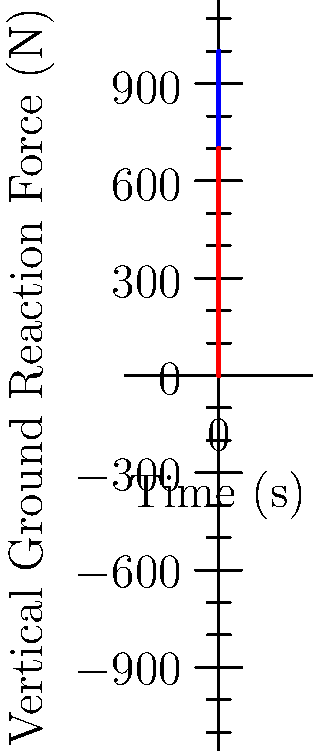The graph shows the vertical ground reaction force (vGRF) patterns during the gait cycle for a non-amputee and a prosthetic limb user. In the context of designing refugee assistance programs, what key biomechanical difference between the two patterns could impact the development of prosthetic limbs and rehabilitation protocols? To answer this question, let's analyze the graph step-by-step:

1. Observe the overall shape of both curves:
   - The non-amputee (blue) curve shows a distinct "M" shape with two clear peaks.
   - The prosthetic limb user (red) curve shows a flatter pattern with less pronounced peaks.

2. Analyze the first peak (initial contact and loading response):
   - For the non-amputee, the first peak reaches about 800 N.
   - For the prosthetic limb user, the first peak is lower, reaching about 600 N.

3. Examine the mid-stance phase (the valley between the peaks):
   - The non-amputee's curve dips to about 600 N.
   - The prosthetic limb user's curve has a shallower dip, only decreasing to about 500 N.

4. Assess the second peak (terminal stance and pre-swing):
   - The non-amputee's second peak is higher, reaching about 1000 N.
   - The prosthetic limb user's second peak is lower, only reaching about 700 N.

5. Consider the implications:
   - The lower peaks in the prosthetic limb user's pattern indicate reduced force production during push-off and less efficient energy transfer.
   - The flatter curve suggests less dynamic control and potentially reduced stability during gait.

The key biomechanical difference is the reduced magnitude of the second peak (push-off force) in the prosthetic limb user's pattern. This difference indicates a decreased ability to generate propulsive force during the terminal stance and pre-swing phases of gait.

This information is crucial for refugee assistance programs because:
- It highlights the need for prosthetic designs that can better mimic natural push-off mechanics.
- It suggests that rehabilitation protocols should focus on exercises to improve push-off strength and control.
- It indicates that energy storage and return in prosthetic feet could be optimized to compensate for this reduced force generation.
Answer: Reduced push-off force in prosthetic limb users 